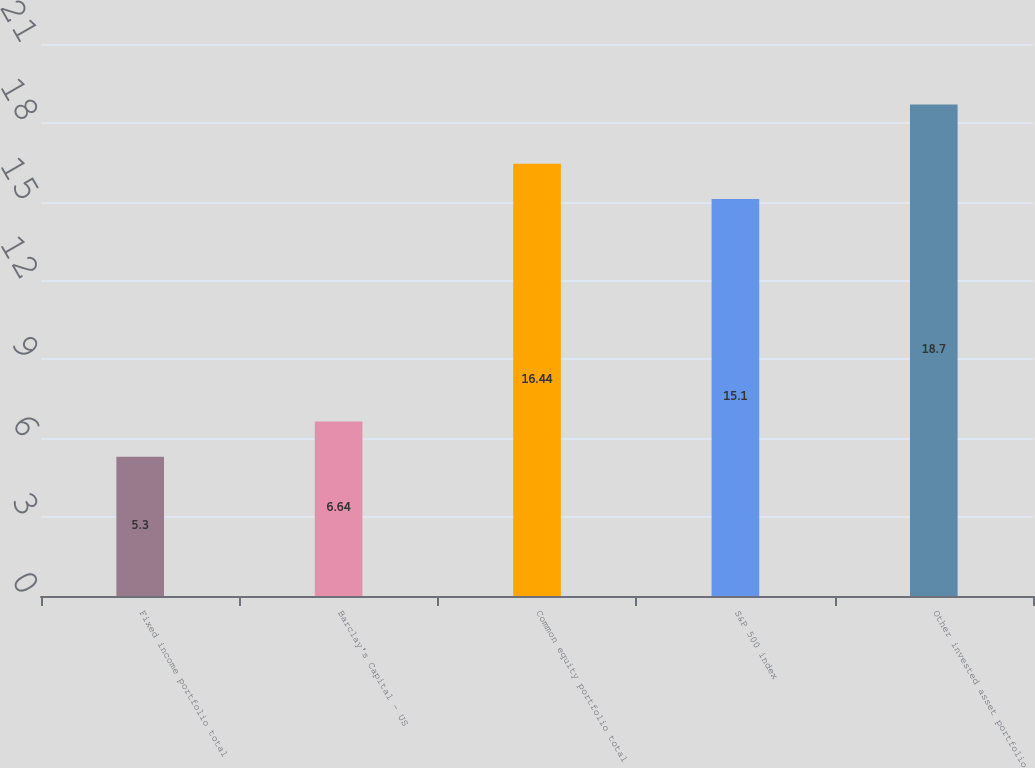Convert chart to OTSL. <chart><loc_0><loc_0><loc_500><loc_500><bar_chart><fcel>Fixed income portfolio total<fcel>Barclay's Capital - US<fcel>Common equity portfolio total<fcel>S&P 500 index<fcel>Other invested asset portfolio<nl><fcel>5.3<fcel>6.64<fcel>16.44<fcel>15.1<fcel>18.7<nl></chart> 